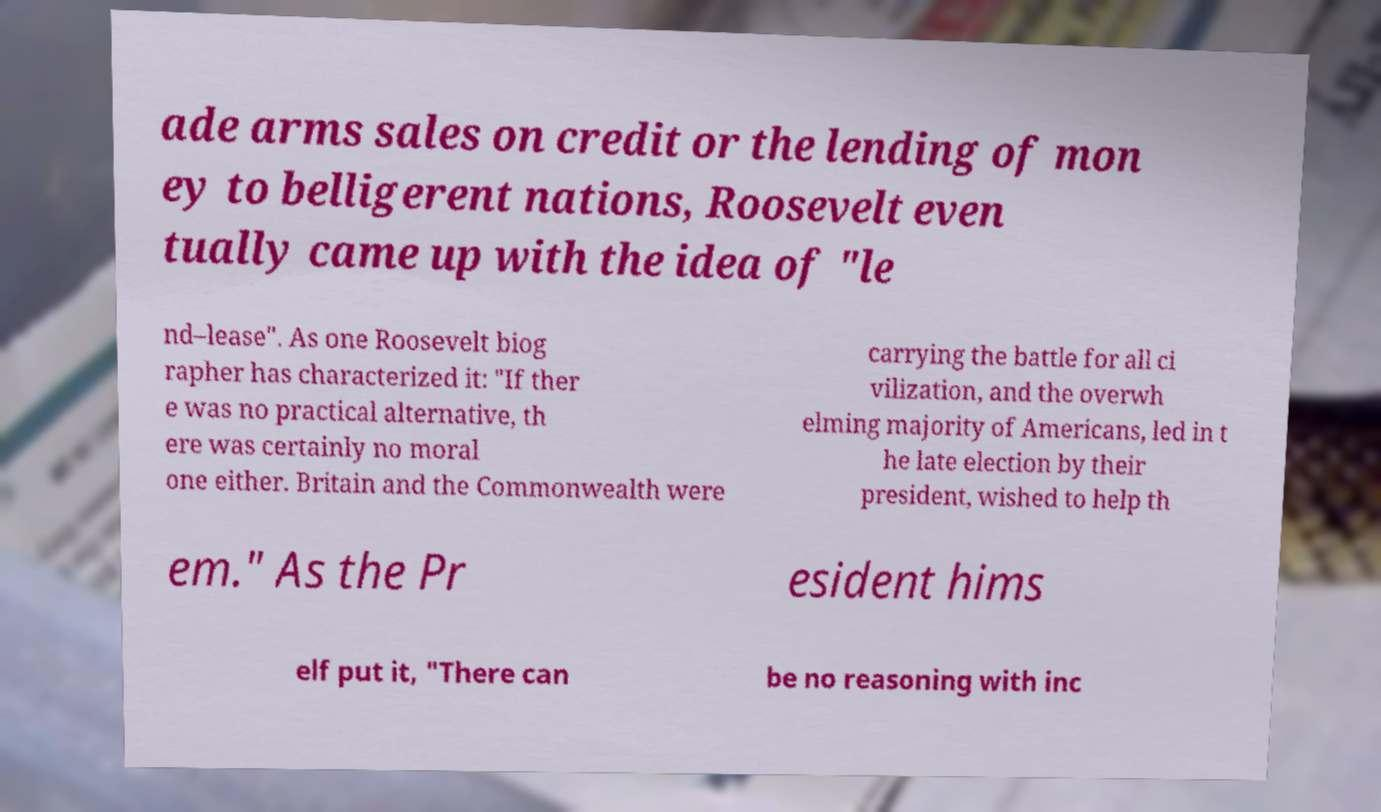For documentation purposes, I need the text within this image transcribed. Could you provide that? ade arms sales on credit or the lending of mon ey to belligerent nations, Roosevelt even tually came up with the idea of "le nd–lease". As one Roosevelt biog rapher has characterized it: "If ther e was no practical alternative, th ere was certainly no moral one either. Britain and the Commonwealth were carrying the battle for all ci vilization, and the overwh elming majority of Americans, led in t he late election by their president, wished to help th em." As the Pr esident hims elf put it, "There can be no reasoning with inc 